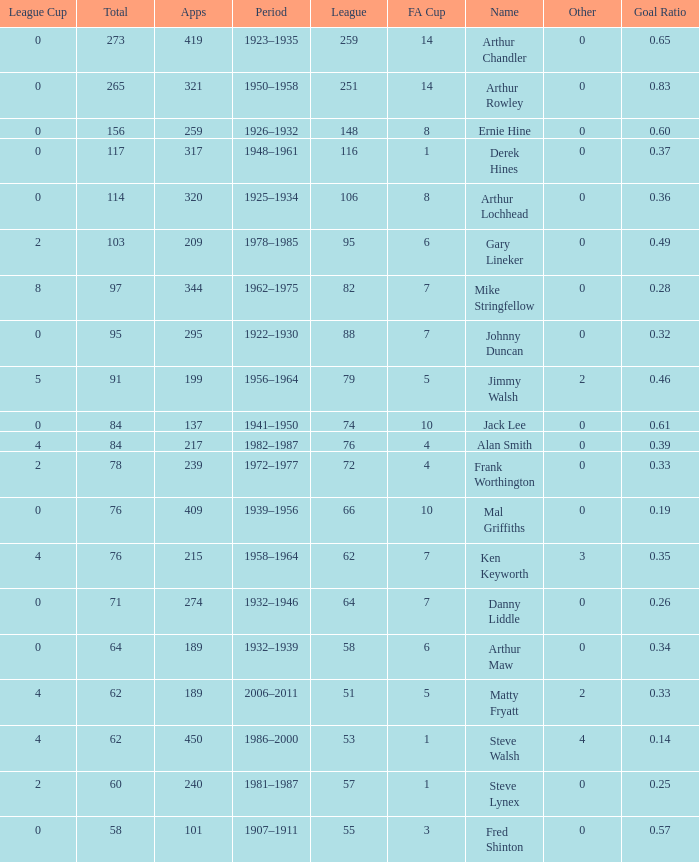What's the lowest Total thats got an FA Cup larger than 10, Name of Arthur Chandler, and a League Cup thats larger than 0? None. Can you give me this table as a dict? {'header': ['League Cup', 'Total', 'Apps', 'Period', 'League', 'FA Cup', 'Name', 'Other', 'Goal Ratio'], 'rows': [['0', '273', '419', '1923–1935', '259', '14', 'Arthur Chandler', '0', '0.65'], ['0', '265', '321', '1950–1958', '251', '14', 'Arthur Rowley', '0', '0.83'], ['0', '156', '259', '1926–1932', '148', '8', 'Ernie Hine', '0', '0.60'], ['0', '117', '317', '1948–1961', '116', '1', 'Derek Hines', '0', '0.37'], ['0', '114', '320', '1925–1934', '106', '8', 'Arthur Lochhead', '0', '0.36'], ['2', '103', '209', '1978–1985', '95', '6', 'Gary Lineker', '0', '0.49'], ['8', '97', '344', '1962–1975', '82', '7', 'Mike Stringfellow', '0', '0.28'], ['0', '95', '295', '1922–1930', '88', '7', 'Johnny Duncan', '0', '0.32'], ['5', '91', '199', '1956–1964', '79', '5', 'Jimmy Walsh', '2', '0.46'], ['0', '84', '137', '1941–1950', '74', '10', 'Jack Lee', '0', '0.61'], ['4', '84', '217', '1982–1987', '76', '4', 'Alan Smith', '0', '0.39'], ['2', '78', '239', '1972–1977', '72', '4', 'Frank Worthington', '0', '0.33'], ['0', '76', '409', '1939–1956', '66', '10', 'Mal Griffiths', '0', '0.19'], ['4', '76', '215', '1958–1964', '62', '7', 'Ken Keyworth', '3', '0.35'], ['0', '71', '274', '1932–1946', '64', '7', 'Danny Liddle', '0', '0.26'], ['0', '64', '189', '1932–1939', '58', '6', 'Arthur Maw', '0', '0.34'], ['4', '62', '189', '2006–2011', '51', '5', 'Matty Fryatt', '2', '0.33'], ['4', '62', '450', '1986–2000', '53', '1', 'Steve Walsh', '4', '0.14'], ['2', '60', '240', '1981–1987', '57', '1', 'Steve Lynex', '0', '0.25'], ['0', '58', '101', '1907–1911', '55', '3', 'Fred Shinton', '0', '0.57']]} 